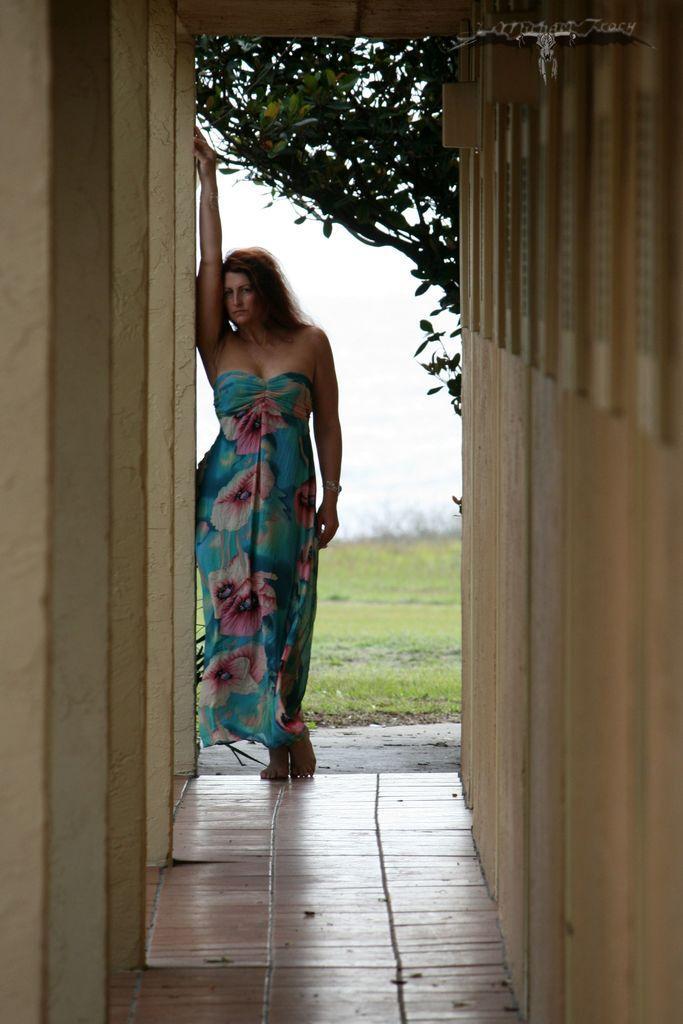Describe this image in one or two sentences. In the foreground I can see a woman is standing on the floor, wall, grass and trees. In the background I can see the sky. This image is taken may be during a day. 